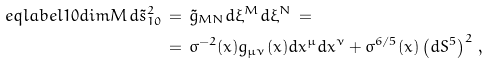<formula> <loc_0><loc_0><loc_500><loc_500>\ e q l a b e l { 1 0 d i m M } d \tilde { s } _ { 1 0 } ^ { 2 } \, & = \, \tilde { g } _ { M N } d \xi ^ { M } d \xi ^ { N } \, = \\ & = \, \sigma ^ { - 2 } ( x ) g _ { \mu \nu } ( x ) d x ^ { \mu } d x ^ { \nu } + \sigma ^ { 6 / 5 } ( x ) \left ( d S ^ { 5 } \right ) ^ { 2 } \, ,</formula> 